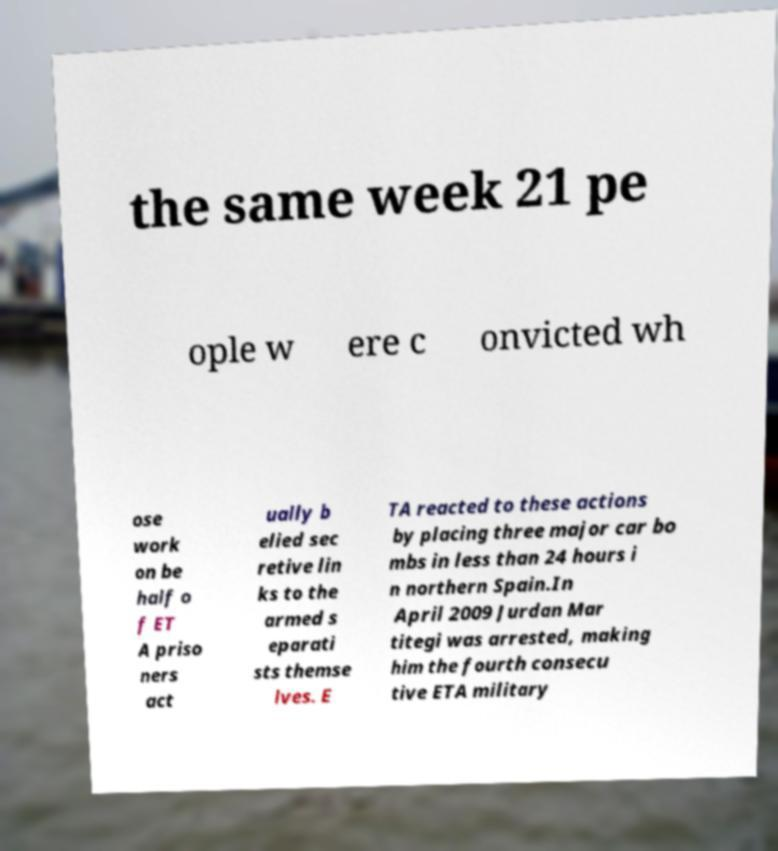There's text embedded in this image that I need extracted. Can you transcribe it verbatim? the same week 21 pe ople w ere c onvicted wh ose work on be half o f ET A priso ners act ually b elied sec retive lin ks to the armed s eparati sts themse lves. E TA reacted to these actions by placing three major car bo mbs in less than 24 hours i n northern Spain.In April 2009 Jurdan Mar titegi was arrested, making him the fourth consecu tive ETA military 